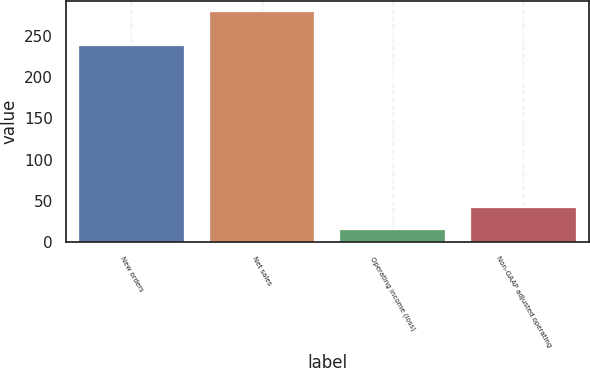Convert chart. <chart><loc_0><loc_0><loc_500><loc_500><bar_chart><fcel>New orders<fcel>Net sales<fcel>Operating income (loss)<fcel>Non-GAAP adjusted operating<nl><fcel>238<fcel>279<fcel>15<fcel>41.4<nl></chart> 